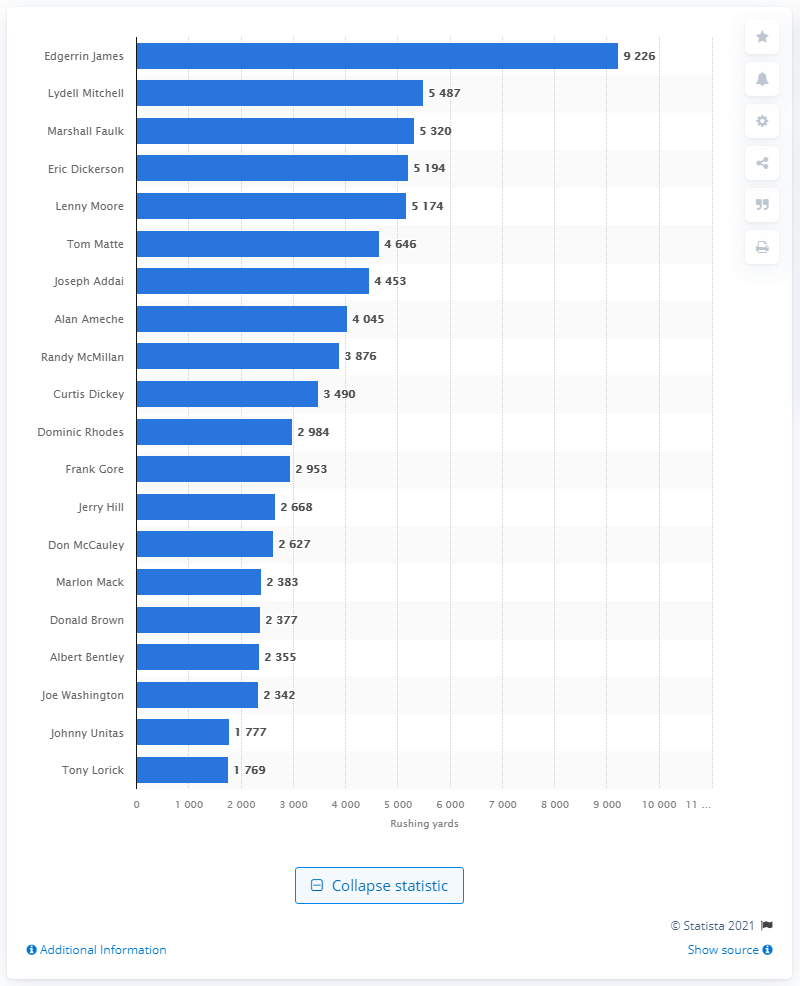Identify some key points in this picture. The career rushing leader of the Indianapolis Colts is Edgerrin James. 